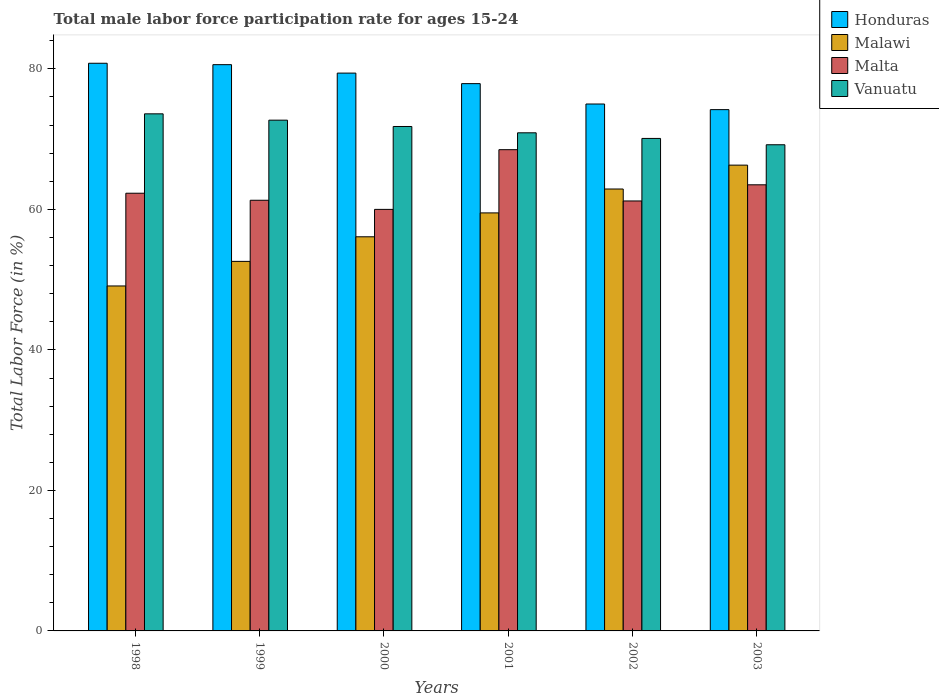How many groups of bars are there?
Provide a short and direct response. 6. How many bars are there on the 1st tick from the right?
Offer a terse response. 4. In how many cases, is the number of bars for a given year not equal to the number of legend labels?
Ensure brevity in your answer.  0. What is the male labor force participation rate in Malawi in 1998?
Your answer should be compact. 49.1. Across all years, what is the maximum male labor force participation rate in Malta?
Make the answer very short. 68.5. Across all years, what is the minimum male labor force participation rate in Malawi?
Your answer should be very brief. 49.1. In which year was the male labor force participation rate in Malta maximum?
Your answer should be compact. 2001. In which year was the male labor force participation rate in Honduras minimum?
Offer a very short reply. 2003. What is the total male labor force participation rate in Malawi in the graph?
Offer a very short reply. 346.5. What is the difference between the male labor force participation rate in Malawi in 1999 and that in 2003?
Offer a very short reply. -13.7. What is the difference between the male labor force participation rate in Malawi in 2000 and the male labor force participation rate in Malta in 2001?
Provide a succinct answer. -12.4. What is the average male labor force participation rate in Honduras per year?
Keep it short and to the point. 77.98. In the year 1998, what is the difference between the male labor force participation rate in Vanuatu and male labor force participation rate in Malta?
Ensure brevity in your answer.  11.3. What is the ratio of the male labor force participation rate in Honduras in 1998 to that in 2003?
Your answer should be compact. 1.09. Is the male labor force participation rate in Vanuatu in 2000 less than that in 2001?
Your answer should be very brief. No. Is the difference between the male labor force participation rate in Vanuatu in 1999 and 2003 greater than the difference between the male labor force participation rate in Malta in 1999 and 2003?
Your answer should be compact. Yes. What is the difference between the highest and the second highest male labor force participation rate in Malta?
Offer a terse response. 5. What is the difference between the highest and the lowest male labor force participation rate in Vanuatu?
Your answer should be very brief. 4.4. In how many years, is the male labor force participation rate in Vanuatu greater than the average male labor force participation rate in Vanuatu taken over all years?
Your answer should be compact. 3. Is it the case that in every year, the sum of the male labor force participation rate in Vanuatu and male labor force participation rate in Honduras is greater than the sum of male labor force participation rate in Malta and male labor force participation rate in Malawi?
Provide a short and direct response. Yes. What does the 1st bar from the left in 2001 represents?
Provide a succinct answer. Honduras. What does the 1st bar from the right in 2003 represents?
Provide a short and direct response. Vanuatu. How many bars are there?
Your answer should be very brief. 24. How many years are there in the graph?
Offer a terse response. 6. Are the values on the major ticks of Y-axis written in scientific E-notation?
Provide a succinct answer. No. Does the graph contain grids?
Your answer should be compact. No. What is the title of the graph?
Your response must be concise. Total male labor force participation rate for ages 15-24. What is the label or title of the X-axis?
Keep it short and to the point. Years. What is the label or title of the Y-axis?
Offer a very short reply. Total Labor Force (in %). What is the Total Labor Force (in %) of Honduras in 1998?
Your answer should be compact. 80.8. What is the Total Labor Force (in %) of Malawi in 1998?
Provide a succinct answer. 49.1. What is the Total Labor Force (in %) of Malta in 1998?
Provide a succinct answer. 62.3. What is the Total Labor Force (in %) in Vanuatu in 1998?
Ensure brevity in your answer.  73.6. What is the Total Labor Force (in %) in Honduras in 1999?
Your response must be concise. 80.6. What is the Total Labor Force (in %) of Malawi in 1999?
Offer a very short reply. 52.6. What is the Total Labor Force (in %) in Malta in 1999?
Make the answer very short. 61.3. What is the Total Labor Force (in %) in Vanuatu in 1999?
Offer a terse response. 72.7. What is the Total Labor Force (in %) of Honduras in 2000?
Offer a very short reply. 79.4. What is the Total Labor Force (in %) of Malawi in 2000?
Your response must be concise. 56.1. What is the Total Labor Force (in %) in Vanuatu in 2000?
Give a very brief answer. 71.8. What is the Total Labor Force (in %) in Honduras in 2001?
Your response must be concise. 77.9. What is the Total Labor Force (in %) in Malawi in 2001?
Your answer should be very brief. 59.5. What is the Total Labor Force (in %) of Malta in 2001?
Make the answer very short. 68.5. What is the Total Labor Force (in %) of Vanuatu in 2001?
Offer a very short reply. 70.9. What is the Total Labor Force (in %) in Honduras in 2002?
Your response must be concise. 75. What is the Total Labor Force (in %) in Malawi in 2002?
Your answer should be compact. 62.9. What is the Total Labor Force (in %) of Malta in 2002?
Offer a terse response. 61.2. What is the Total Labor Force (in %) in Vanuatu in 2002?
Offer a very short reply. 70.1. What is the Total Labor Force (in %) in Honduras in 2003?
Provide a succinct answer. 74.2. What is the Total Labor Force (in %) of Malawi in 2003?
Make the answer very short. 66.3. What is the Total Labor Force (in %) of Malta in 2003?
Your response must be concise. 63.5. What is the Total Labor Force (in %) in Vanuatu in 2003?
Your answer should be very brief. 69.2. Across all years, what is the maximum Total Labor Force (in %) in Honduras?
Provide a succinct answer. 80.8. Across all years, what is the maximum Total Labor Force (in %) in Malawi?
Ensure brevity in your answer.  66.3. Across all years, what is the maximum Total Labor Force (in %) in Malta?
Make the answer very short. 68.5. Across all years, what is the maximum Total Labor Force (in %) of Vanuatu?
Keep it short and to the point. 73.6. Across all years, what is the minimum Total Labor Force (in %) in Honduras?
Keep it short and to the point. 74.2. Across all years, what is the minimum Total Labor Force (in %) of Malawi?
Your answer should be compact. 49.1. Across all years, what is the minimum Total Labor Force (in %) of Vanuatu?
Make the answer very short. 69.2. What is the total Total Labor Force (in %) in Honduras in the graph?
Your answer should be very brief. 467.9. What is the total Total Labor Force (in %) in Malawi in the graph?
Your answer should be compact. 346.5. What is the total Total Labor Force (in %) of Malta in the graph?
Provide a succinct answer. 376.8. What is the total Total Labor Force (in %) of Vanuatu in the graph?
Provide a short and direct response. 428.3. What is the difference between the Total Labor Force (in %) in Honduras in 1998 and that in 1999?
Make the answer very short. 0.2. What is the difference between the Total Labor Force (in %) of Malawi in 1998 and that in 1999?
Keep it short and to the point. -3.5. What is the difference between the Total Labor Force (in %) in Honduras in 1998 and that in 2000?
Your response must be concise. 1.4. What is the difference between the Total Labor Force (in %) of Malawi in 1998 and that in 2000?
Offer a very short reply. -7. What is the difference between the Total Labor Force (in %) in Honduras in 1998 and that in 2001?
Offer a very short reply. 2.9. What is the difference between the Total Labor Force (in %) in Malta in 1998 and that in 2001?
Give a very brief answer. -6.2. What is the difference between the Total Labor Force (in %) in Honduras in 1998 and that in 2002?
Provide a succinct answer. 5.8. What is the difference between the Total Labor Force (in %) of Malta in 1998 and that in 2002?
Your answer should be compact. 1.1. What is the difference between the Total Labor Force (in %) of Vanuatu in 1998 and that in 2002?
Give a very brief answer. 3.5. What is the difference between the Total Labor Force (in %) in Honduras in 1998 and that in 2003?
Give a very brief answer. 6.6. What is the difference between the Total Labor Force (in %) in Malawi in 1998 and that in 2003?
Provide a short and direct response. -17.2. What is the difference between the Total Labor Force (in %) in Malta in 1998 and that in 2003?
Your response must be concise. -1.2. What is the difference between the Total Labor Force (in %) of Vanuatu in 1998 and that in 2003?
Offer a terse response. 4.4. What is the difference between the Total Labor Force (in %) in Malawi in 1999 and that in 2001?
Offer a very short reply. -6.9. What is the difference between the Total Labor Force (in %) in Malta in 1999 and that in 2001?
Your answer should be very brief. -7.2. What is the difference between the Total Labor Force (in %) of Honduras in 1999 and that in 2002?
Provide a short and direct response. 5.6. What is the difference between the Total Labor Force (in %) in Malawi in 1999 and that in 2003?
Offer a very short reply. -13.7. What is the difference between the Total Labor Force (in %) of Malta in 1999 and that in 2003?
Offer a terse response. -2.2. What is the difference between the Total Labor Force (in %) of Honduras in 2000 and that in 2001?
Your answer should be very brief. 1.5. What is the difference between the Total Labor Force (in %) in Malawi in 2000 and that in 2001?
Your answer should be very brief. -3.4. What is the difference between the Total Labor Force (in %) in Vanuatu in 2000 and that in 2001?
Provide a short and direct response. 0.9. What is the difference between the Total Labor Force (in %) in Malawi in 2000 and that in 2002?
Your response must be concise. -6.8. What is the difference between the Total Labor Force (in %) of Malawi in 2001 and that in 2002?
Give a very brief answer. -3.4. What is the difference between the Total Labor Force (in %) of Vanuatu in 2001 and that in 2003?
Your answer should be compact. 1.7. What is the difference between the Total Labor Force (in %) in Malta in 2002 and that in 2003?
Make the answer very short. -2.3. What is the difference between the Total Labor Force (in %) in Vanuatu in 2002 and that in 2003?
Offer a terse response. 0.9. What is the difference between the Total Labor Force (in %) in Honduras in 1998 and the Total Labor Force (in %) in Malawi in 1999?
Offer a terse response. 28.2. What is the difference between the Total Labor Force (in %) in Honduras in 1998 and the Total Labor Force (in %) in Vanuatu in 1999?
Provide a short and direct response. 8.1. What is the difference between the Total Labor Force (in %) in Malawi in 1998 and the Total Labor Force (in %) in Malta in 1999?
Your answer should be compact. -12.2. What is the difference between the Total Labor Force (in %) in Malawi in 1998 and the Total Labor Force (in %) in Vanuatu in 1999?
Your answer should be compact. -23.6. What is the difference between the Total Labor Force (in %) in Honduras in 1998 and the Total Labor Force (in %) in Malawi in 2000?
Keep it short and to the point. 24.7. What is the difference between the Total Labor Force (in %) of Honduras in 1998 and the Total Labor Force (in %) of Malta in 2000?
Give a very brief answer. 20.8. What is the difference between the Total Labor Force (in %) in Malawi in 1998 and the Total Labor Force (in %) in Malta in 2000?
Ensure brevity in your answer.  -10.9. What is the difference between the Total Labor Force (in %) of Malawi in 1998 and the Total Labor Force (in %) of Vanuatu in 2000?
Your response must be concise. -22.7. What is the difference between the Total Labor Force (in %) in Honduras in 1998 and the Total Labor Force (in %) in Malawi in 2001?
Your answer should be very brief. 21.3. What is the difference between the Total Labor Force (in %) in Honduras in 1998 and the Total Labor Force (in %) in Malta in 2001?
Your response must be concise. 12.3. What is the difference between the Total Labor Force (in %) in Malawi in 1998 and the Total Labor Force (in %) in Malta in 2001?
Make the answer very short. -19.4. What is the difference between the Total Labor Force (in %) in Malawi in 1998 and the Total Labor Force (in %) in Vanuatu in 2001?
Keep it short and to the point. -21.8. What is the difference between the Total Labor Force (in %) in Malta in 1998 and the Total Labor Force (in %) in Vanuatu in 2001?
Provide a succinct answer. -8.6. What is the difference between the Total Labor Force (in %) in Honduras in 1998 and the Total Labor Force (in %) in Malta in 2002?
Your response must be concise. 19.6. What is the difference between the Total Labor Force (in %) of Honduras in 1998 and the Total Labor Force (in %) of Malawi in 2003?
Offer a very short reply. 14.5. What is the difference between the Total Labor Force (in %) of Honduras in 1998 and the Total Labor Force (in %) of Malta in 2003?
Your response must be concise. 17.3. What is the difference between the Total Labor Force (in %) in Honduras in 1998 and the Total Labor Force (in %) in Vanuatu in 2003?
Your answer should be compact. 11.6. What is the difference between the Total Labor Force (in %) of Malawi in 1998 and the Total Labor Force (in %) of Malta in 2003?
Ensure brevity in your answer.  -14.4. What is the difference between the Total Labor Force (in %) of Malawi in 1998 and the Total Labor Force (in %) of Vanuatu in 2003?
Give a very brief answer. -20.1. What is the difference between the Total Labor Force (in %) of Honduras in 1999 and the Total Labor Force (in %) of Malta in 2000?
Keep it short and to the point. 20.6. What is the difference between the Total Labor Force (in %) in Malawi in 1999 and the Total Labor Force (in %) in Vanuatu in 2000?
Offer a very short reply. -19.2. What is the difference between the Total Labor Force (in %) of Honduras in 1999 and the Total Labor Force (in %) of Malawi in 2001?
Provide a succinct answer. 21.1. What is the difference between the Total Labor Force (in %) in Honduras in 1999 and the Total Labor Force (in %) in Malta in 2001?
Offer a terse response. 12.1. What is the difference between the Total Labor Force (in %) in Honduras in 1999 and the Total Labor Force (in %) in Vanuatu in 2001?
Your answer should be compact. 9.7. What is the difference between the Total Labor Force (in %) in Malawi in 1999 and the Total Labor Force (in %) in Malta in 2001?
Offer a very short reply. -15.9. What is the difference between the Total Labor Force (in %) in Malawi in 1999 and the Total Labor Force (in %) in Vanuatu in 2001?
Offer a terse response. -18.3. What is the difference between the Total Labor Force (in %) of Honduras in 1999 and the Total Labor Force (in %) of Malta in 2002?
Offer a very short reply. 19.4. What is the difference between the Total Labor Force (in %) of Honduras in 1999 and the Total Labor Force (in %) of Vanuatu in 2002?
Ensure brevity in your answer.  10.5. What is the difference between the Total Labor Force (in %) of Malawi in 1999 and the Total Labor Force (in %) of Vanuatu in 2002?
Offer a very short reply. -17.5. What is the difference between the Total Labor Force (in %) in Honduras in 1999 and the Total Labor Force (in %) in Malta in 2003?
Your response must be concise. 17.1. What is the difference between the Total Labor Force (in %) of Honduras in 1999 and the Total Labor Force (in %) of Vanuatu in 2003?
Give a very brief answer. 11.4. What is the difference between the Total Labor Force (in %) of Malawi in 1999 and the Total Labor Force (in %) of Malta in 2003?
Offer a terse response. -10.9. What is the difference between the Total Labor Force (in %) in Malawi in 1999 and the Total Labor Force (in %) in Vanuatu in 2003?
Make the answer very short. -16.6. What is the difference between the Total Labor Force (in %) in Malta in 1999 and the Total Labor Force (in %) in Vanuatu in 2003?
Your answer should be very brief. -7.9. What is the difference between the Total Labor Force (in %) in Honduras in 2000 and the Total Labor Force (in %) in Malawi in 2001?
Make the answer very short. 19.9. What is the difference between the Total Labor Force (in %) in Malawi in 2000 and the Total Labor Force (in %) in Vanuatu in 2001?
Offer a terse response. -14.8. What is the difference between the Total Labor Force (in %) of Honduras in 2000 and the Total Labor Force (in %) of Vanuatu in 2002?
Keep it short and to the point. 9.3. What is the difference between the Total Labor Force (in %) of Honduras in 2000 and the Total Labor Force (in %) of Malawi in 2003?
Give a very brief answer. 13.1. What is the difference between the Total Labor Force (in %) of Honduras in 2000 and the Total Labor Force (in %) of Malta in 2003?
Keep it short and to the point. 15.9. What is the difference between the Total Labor Force (in %) in Honduras in 2000 and the Total Labor Force (in %) in Vanuatu in 2003?
Your answer should be compact. 10.2. What is the difference between the Total Labor Force (in %) of Honduras in 2001 and the Total Labor Force (in %) of Malawi in 2002?
Offer a terse response. 15. What is the difference between the Total Labor Force (in %) in Honduras in 2001 and the Total Labor Force (in %) in Vanuatu in 2002?
Offer a very short reply. 7.8. What is the difference between the Total Labor Force (in %) in Honduras in 2001 and the Total Labor Force (in %) in Malawi in 2003?
Give a very brief answer. 11.6. What is the difference between the Total Labor Force (in %) in Malawi in 2001 and the Total Labor Force (in %) in Vanuatu in 2003?
Your answer should be compact. -9.7. What is the difference between the Total Labor Force (in %) of Malta in 2002 and the Total Labor Force (in %) of Vanuatu in 2003?
Your answer should be very brief. -8. What is the average Total Labor Force (in %) in Honduras per year?
Your answer should be very brief. 77.98. What is the average Total Labor Force (in %) of Malawi per year?
Ensure brevity in your answer.  57.75. What is the average Total Labor Force (in %) of Malta per year?
Your answer should be compact. 62.8. What is the average Total Labor Force (in %) in Vanuatu per year?
Offer a terse response. 71.38. In the year 1998, what is the difference between the Total Labor Force (in %) of Honduras and Total Labor Force (in %) of Malawi?
Provide a short and direct response. 31.7. In the year 1998, what is the difference between the Total Labor Force (in %) in Malawi and Total Labor Force (in %) in Malta?
Your answer should be very brief. -13.2. In the year 1998, what is the difference between the Total Labor Force (in %) in Malawi and Total Labor Force (in %) in Vanuatu?
Offer a terse response. -24.5. In the year 1999, what is the difference between the Total Labor Force (in %) of Honduras and Total Labor Force (in %) of Malta?
Give a very brief answer. 19.3. In the year 1999, what is the difference between the Total Labor Force (in %) of Malawi and Total Labor Force (in %) of Malta?
Your answer should be very brief. -8.7. In the year 1999, what is the difference between the Total Labor Force (in %) of Malawi and Total Labor Force (in %) of Vanuatu?
Provide a short and direct response. -20.1. In the year 1999, what is the difference between the Total Labor Force (in %) of Malta and Total Labor Force (in %) of Vanuatu?
Ensure brevity in your answer.  -11.4. In the year 2000, what is the difference between the Total Labor Force (in %) in Honduras and Total Labor Force (in %) in Malawi?
Ensure brevity in your answer.  23.3. In the year 2000, what is the difference between the Total Labor Force (in %) in Malawi and Total Labor Force (in %) in Malta?
Your answer should be very brief. -3.9. In the year 2000, what is the difference between the Total Labor Force (in %) in Malawi and Total Labor Force (in %) in Vanuatu?
Give a very brief answer. -15.7. In the year 2001, what is the difference between the Total Labor Force (in %) of Honduras and Total Labor Force (in %) of Malawi?
Offer a terse response. 18.4. In the year 2001, what is the difference between the Total Labor Force (in %) in Honduras and Total Labor Force (in %) in Malta?
Keep it short and to the point. 9.4. In the year 2001, what is the difference between the Total Labor Force (in %) in Malawi and Total Labor Force (in %) in Vanuatu?
Your answer should be compact. -11.4. In the year 2002, what is the difference between the Total Labor Force (in %) of Honduras and Total Labor Force (in %) of Malawi?
Ensure brevity in your answer.  12.1. In the year 2002, what is the difference between the Total Labor Force (in %) of Honduras and Total Labor Force (in %) of Malta?
Provide a succinct answer. 13.8. In the year 2002, what is the difference between the Total Labor Force (in %) in Honduras and Total Labor Force (in %) in Vanuatu?
Keep it short and to the point. 4.9. In the year 2002, what is the difference between the Total Labor Force (in %) in Malawi and Total Labor Force (in %) in Vanuatu?
Give a very brief answer. -7.2. What is the ratio of the Total Labor Force (in %) in Malawi in 1998 to that in 1999?
Make the answer very short. 0.93. What is the ratio of the Total Labor Force (in %) in Malta in 1998 to that in 1999?
Provide a short and direct response. 1.02. What is the ratio of the Total Labor Force (in %) of Vanuatu in 1998 to that in 1999?
Make the answer very short. 1.01. What is the ratio of the Total Labor Force (in %) of Honduras in 1998 to that in 2000?
Offer a terse response. 1.02. What is the ratio of the Total Labor Force (in %) in Malawi in 1998 to that in 2000?
Provide a succinct answer. 0.88. What is the ratio of the Total Labor Force (in %) of Malta in 1998 to that in 2000?
Your response must be concise. 1.04. What is the ratio of the Total Labor Force (in %) in Vanuatu in 1998 to that in 2000?
Give a very brief answer. 1.03. What is the ratio of the Total Labor Force (in %) of Honduras in 1998 to that in 2001?
Keep it short and to the point. 1.04. What is the ratio of the Total Labor Force (in %) in Malawi in 1998 to that in 2001?
Your answer should be compact. 0.83. What is the ratio of the Total Labor Force (in %) in Malta in 1998 to that in 2001?
Your answer should be very brief. 0.91. What is the ratio of the Total Labor Force (in %) in Vanuatu in 1998 to that in 2001?
Your answer should be compact. 1.04. What is the ratio of the Total Labor Force (in %) in Honduras in 1998 to that in 2002?
Keep it short and to the point. 1.08. What is the ratio of the Total Labor Force (in %) of Malawi in 1998 to that in 2002?
Offer a terse response. 0.78. What is the ratio of the Total Labor Force (in %) in Vanuatu in 1998 to that in 2002?
Offer a terse response. 1.05. What is the ratio of the Total Labor Force (in %) of Honduras in 1998 to that in 2003?
Your answer should be compact. 1.09. What is the ratio of the Total Labor Force (in %) in Malawi in 1998 to that in 2003?
Offer a very short reply. 0.74. What is the ratio of the Total Labor Force (in %) of Malta in 1998 to that in 2003?
Keep it short and to the point. 0.98. What is the ratio of the Total Labor Force (in %) of Vanuatu in 1998 to that in 2003?
Offer a very short reply. 1.06. What is the ratio of the Total Labor Force (in %) in Honduras in 1999 to that in 2000?
Make the answer very short. 1.02. What is the ratio of the Total Labor Force (in %) of Malawi in 1999 to that in 2000?
Ensure brevity in your answer.  0.94. What is the ratio of the Total Labor Force (in %) of Malta in 1999 to that in 2000?
Provide a short and direct response. 1.02. What is the ratio of the Total Labor Force (in %) in Vanuatu in 1999 to that in 2000?
Give a very brief answer. 1.01. What is the ratio of the Total Labor Force (in %) in Honduras in 1999 to that in 2001?
Offer a very short reply. 1.03. What is the ratio of the Total Labor Force (in %) of Malawi in 1999 to that in 2001?
Provide a short and direct response. 0.88. What is the ratio of the Total Labor Force (in %) in Malta in 1999 to that in 2001?
Keep it short and to the point. 0.89. What is the ratio of the Total Labor Force (in %) in Vanuatu in 1999 to that in 2001?
Offer a very short reply. 1.03. What is the ratio of the Total Labor Force (in %) in Honduras in 1999 to that in 2002?
Ensure brevity in your answer.  1.07. What is the ratio of the Total Labor Force (in %) of Malawi in 1999 to that in 2002?
Your answer should be very brief. 0.84. What is the ratio of the Total Labor Force (in %) of Vanuatu in 1999 to that in 2002?
Give a very brief answer. 1.04. What is the ratio of the Total Labor Force (in %) in Honduras in 1999 to that in 2003?
Ensure brevity in your answer.  1.09. What is the ratio of the Total Labor Force (in %) in Malawi in 1999 to that in 2003?
Give a very brief answer. 0.79. What is the ratio of the Total Labor Force (in %) in Malta in 1999 to that in 2003?
Your answer should be compact. 0.97. What is the ratio of the Total Labor Force (in %) in Vanuatu in 1999 to that in 2003?
Provide a succinct answer. 1.05. What is the ratio of the Total Labor Force (in %) in Honduras in 2000 to that in 2001?
Make the answer very short. 1.02. What is the ratio of the Total Labor Force (in %) in Malawi in 2000 to that in 2001?
Make the answer very short. 0.94. What is the ratio of the Total Labor Force (in %) of Malta in 2000 to that in 2001?
Your response must be concise. 0.88. What is the ratio of the Total Labor Force (in %) of Vanuatu in 2000 to that in 2001?
Your response must be concise. 1.01. What is the ratio of the Total Labor Force (in %) in Honduras in 2000 to that in 2002?
Your answer should be compact. 1.06. What is the ratio of the Total Labor Force (in %) of Malawi in 2000 to that in 2002?
Ensure brevity in your answer.  0.89. What is the ratio of the Total Labor Force (in %) in Malta in 2000 to that in 2002?
Your response must be concise. 0.98. What is the ratio of the Total Labor Force (in %) of Vanuatu in 2000 to that in 2002?
Your answer should be compact. 1.02. What is the ratio of the Total Labor Force (in %) in Honduras in 2000 to that in 2003?
Ensure brevity in your answer.  1.07. What is the ratio of the Total Labor Force (in %) of Malawi in 2000 to that in 2003?
Ensure brevity in your answer.  0.85. What is the ratio of the Total Labor Force (in %) in Malta in 2000 to that in 2003?
Keep it short and to the point. 0.94. What is the ratio of the Total Labor Force (in %) of Vanuatu in 2000 to that in 2003?
Give a very brief answer. 1.04. What is the ratio of the Total Labor Force (in %) of Honduras in 2001 to that in 2002?
Offer a very short reply. 1.04. What is the ratio of the Total Labor Force (in %) of Malawi in 2001 to that in 2002?
Your answer should be very brief. 0.95. What is the ratio of the Total Labor Force (in %) of Malta in 2001 to that in 2002?
Provide a succinct answer. 1.12. What is the ratio of the Total Labor Force (in %) in Vanuatu in 2001 to that in 2002?
Make the answer very short. 1.01. What is the ratio of the Total Labor Force (in %) of Honduras in 2001 to that in 2003?
Make the answer very short. 1.05. What is the ratio of the Total Labor Force (in %) of Malawi in 2001 to that in 2003?
Provide a short and direct response. 0.9. What is the ratio of the Total Labor Force (in %) in Malta in 2001 to that in 2003?
Give a very brief answer. 1.08. What is the ratio of the Total Labor Force (in %) in Vanuatu in 2001 to that in 2003?
Your response must be concise. 1.02. What is the ratio of the Total Labor Force (in %) of Honduras in 2002 to that in 2003?
Your response must be concise. 1.01. What is the ratio of the Total Labor Force (in %) in Malawi in 2002 to that in 2003?
Offer a terse response. 0.95. What is the ratio of the Total Labor Force (in %) in Malta in 2002 to that in 2003?
Your answer should be compact. 0.96. What is the difference between the highest and the second highest Total Labor Force (in %) of Honduras?
Your response must be concise. 0.2. What is the difference between the highest and the second highest Total Labor Force (in %) in Malta?
Your response must be concise. 5. What is the difference between the highest and the second highest Total Labor Force (in %) of Vanuatu?
Keep it short and to the point. 0.9. What is the difference between the highest and the lowest Total Labor Force (in %) of Malawi?
Your response must be concise. 17.2. 